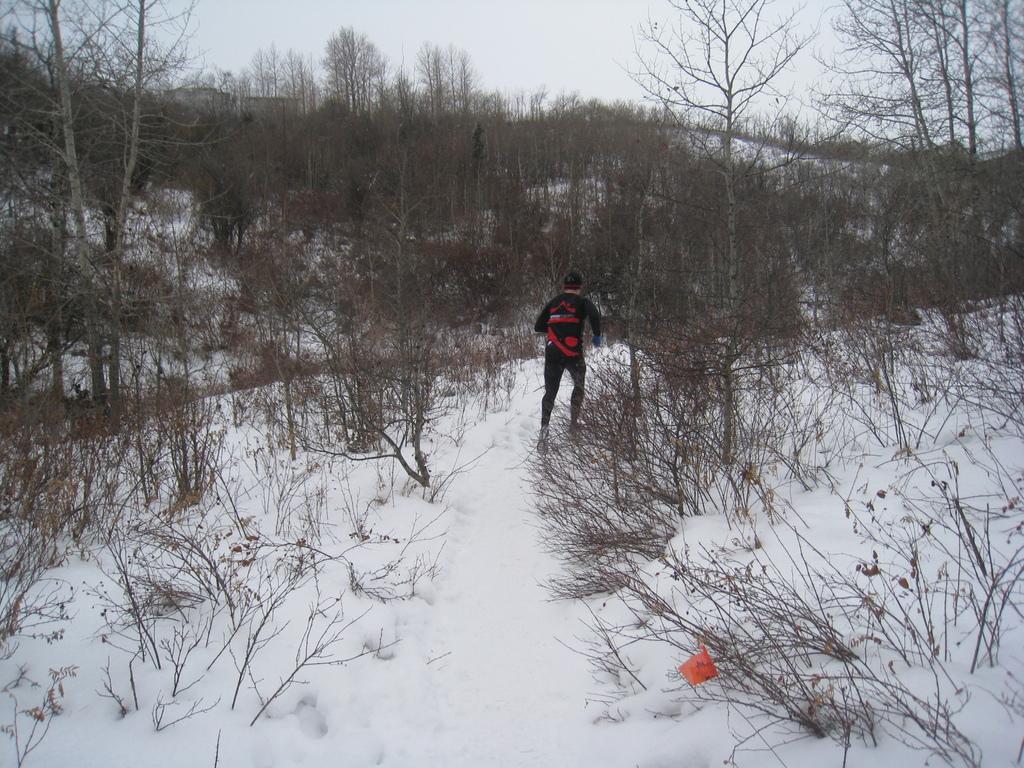In one or two sentences, can you explain what this image depicts? In this image I can see in the middle a man is running on the snow and there are trees, at the top it is the sky. 